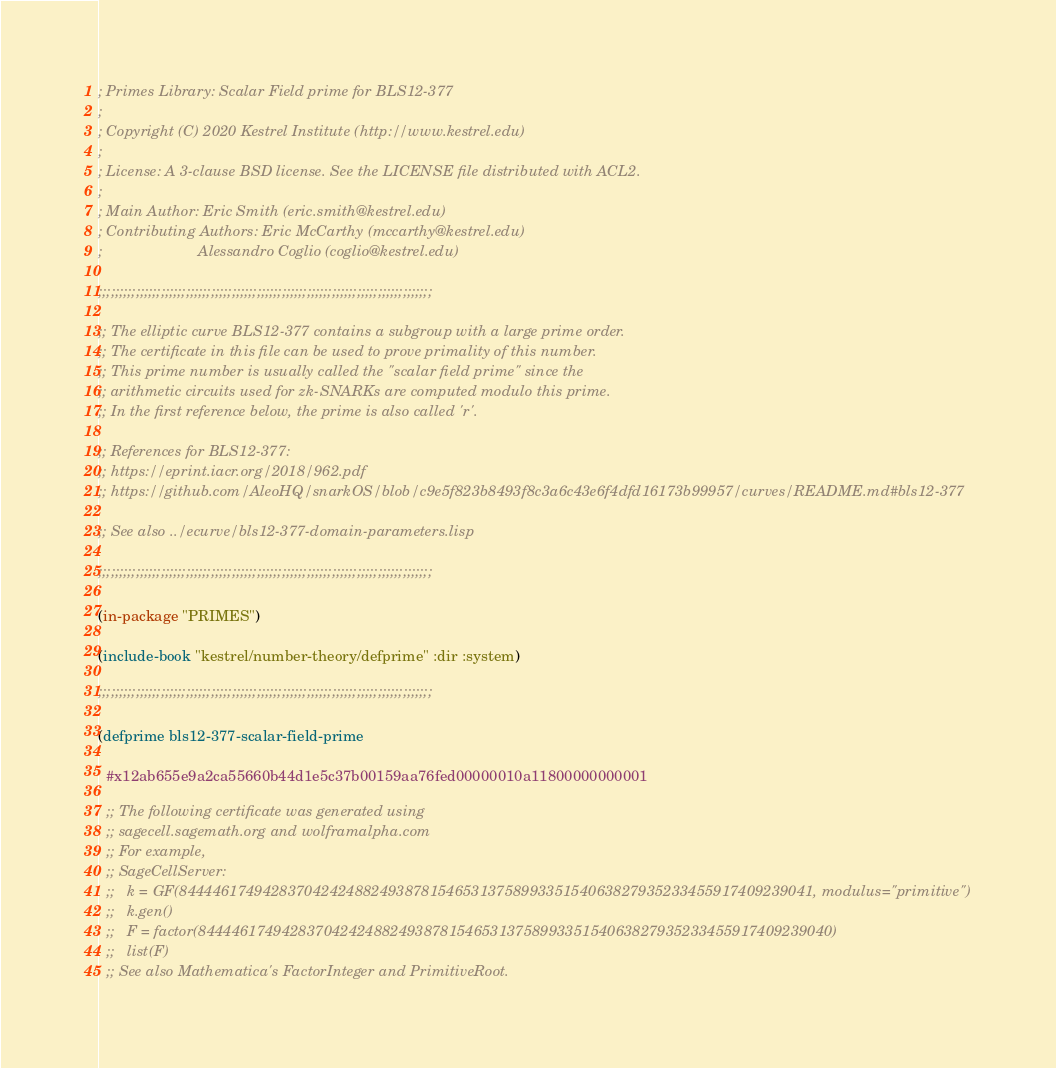Convert code to text. <code><loc_0><loc_0><loc_500><loc_500><_Lisp_>; Primes Library: Scalar Field prime for BLS12-377
;
; Copyright (C) 2020 Kestrel Institute (http://www.kestrel.edu)
;
; License: A 3-clause BSD license. See the LICENSE file distributed with ACL2.
;
; Main Author: Eric Smith (eric.smith@kestrel.edu)
; Contributing Authors: Eric McCarthy (mccarthy@kestrel.edu)
;                       Alessandro Coglio (coglio@kestrel.edu)

;;;;;;;;;;;;;;;;;;;;;;;;;;;;;;;;;;;;;;;;;;;;;;;;;;;;;;;;;;;;;;;;;;;;;;;;;;;;;;;;

;; The elliptic curve BLS12-377 contains a subgroup with a large prime order.
;; The certificate in this file can be used to prove primality of this number.
;; This prime number is usually called the "scalar field prime" since the
;; arithmetic circuits used for zk-SNARKs are computed modulo this prime.
;; In the first reference below, the prime is also called 'r'.

;; References for BLS12-377:
;; https://eprint.iacr.org/2018/962.pdf
;; https://github.com/AleoHQ/snarkOS/blob/c9e5f823b8493f8c3a6c43e6f4dfd16173b99957/curves/README.md#bls12-377

;; See also ../ecurve/bls12-377-domain-parameters.lisp

;;;;;;;;;;;;;;;;;;;;;;;;;;;;;;;;;;;;;;;;;;;;;;;;;;;;;;;;;;;;;;;;;;;;;;;;;;;;;;;;

(in-package "PRIMES")

(include-book "kestrel/number-theory/defprime" :dir :system)

;;;;;;;;;;;;;;;;;;;;;;;;;;;;;;;;;;;;;;;;;;;;;;;;;;;;;;;;;;;;;;;;;;;;;;;;;;;;;;;;

(defprime bls12-377-scalar-field-prime

  #x12ab655e9a2ca55660b44d1e5c37b00159aa76fed00000010a11800000000001

  ;; The following certificate was generated using
  ;; sagecell.sagemath.org and wolframalpha.com
  ;; For example,
  ;; SageCellServer:
  ;;   k = GF(8444461749428370424248824938781546531375899335154063827935233455917409239041, modulus="primitive")
  ;;   k.gen()
  ;;   F = factor(8444461749428370424248824938781546531375899335154063827935233455917409239040)
  ;;   list(F)
  ;; See also Mathematica's FactorInteger and PrimitiveRoot.</code> 